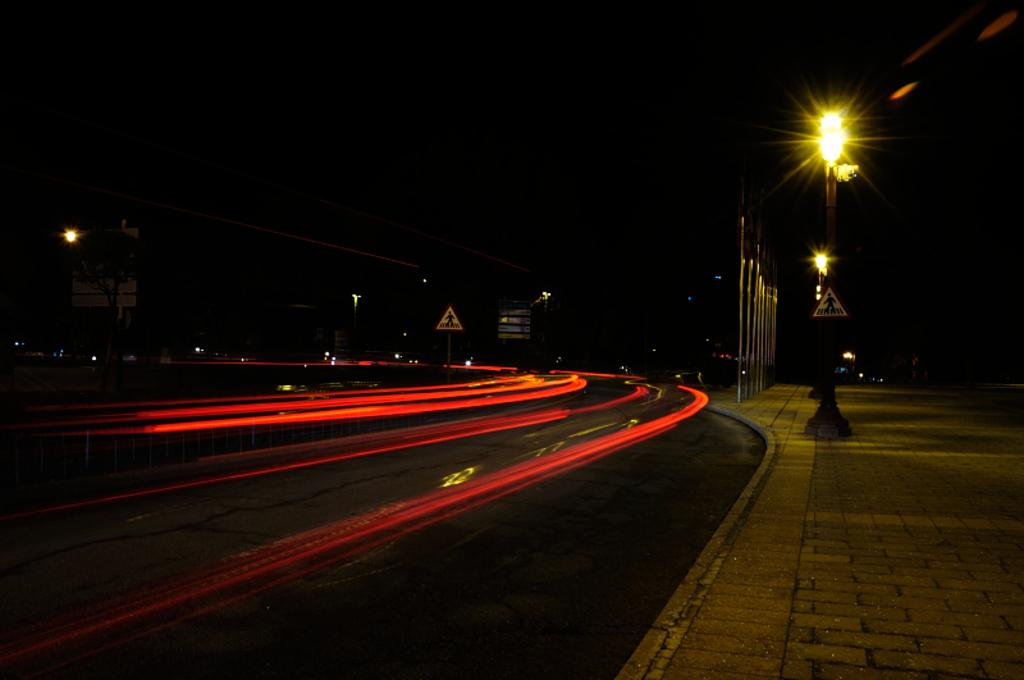What objects can be seen in the image? There are poles, lights, and sign boards in the image. What is the condition of the background in the image? The background of the image is dark. Can you tell me how many girls are wearing vests in the image? There are no girls or vests present in the image. What is the total amount of debt visible in the image? There is no mention of debt in the image. 